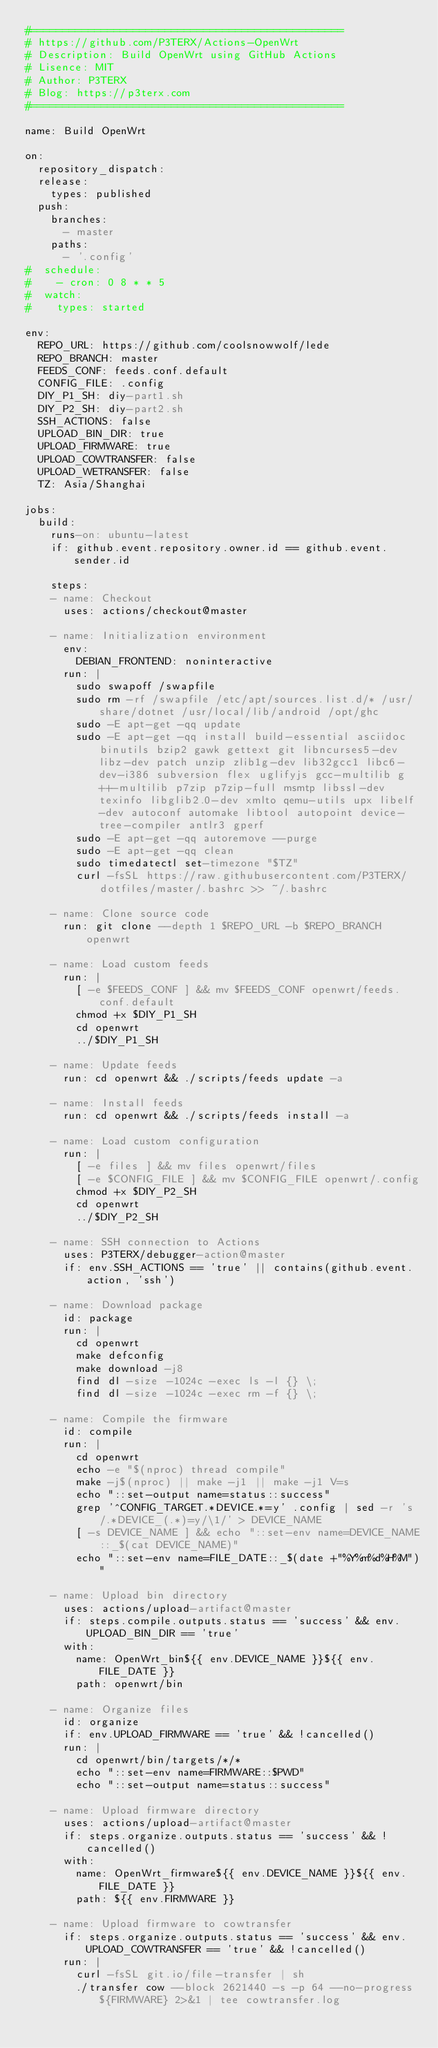<code> <loc_0><loc_0><loc_500><loc_500><_YAML_>#=================================================
# https://github.com/P3TERX/Actions-OpenWrt
# Description: Build OpenWrt using GitHub Actions
# Lisence: MIT
# Author: P3TERX
# Blog: https://p3terx.com
#=================================================

name: Build OpenWrt

on:
  repository_dispatch:
  release:
    types: published
  push:
    branches:
      - master
    paths:
      - '.config'
#  schedule:
#    - cron: 0 8 * * 5
#  watch:
#    types: started

env:
  REPO_URL: https://github.com/coolsnowwolf/lede
  REPO_BRANCH: master
  FEEDS_CONF: feeds.conf.default
  CONFIG_FILE: .config
  DIY_P1_SH: diy-part1.sh
  DIY_P2_SH: diy-part2.sh
  SSH_ACTIONS: false
  UPLOAD_BIN_DIR: true
  UPLOAD_FIRMWARE: true
  UPLOAD_COWTRANSFER: false
  UPLOAD_WETRANSFER: false
  TZ: Asia/Shanghai

jobs:
  build:
    runs-on: ubuntu-latest
    if: github.event.repository.owner.id == github.event.sender.id

    steps:
    - name: Checkout
      uses: actions/checkout@master

    - name: Initialization environment
      env:
        DEBIAN_FRONTEND: noninteractive
      run: |
        sudo swapoff /swapfile
        sudo rm -rf /swapfile /etc/apt/sources.list.d/* /usr/share/dotnet /usr/local/lib/android /opt/ghc
        sudo -E apt-get -qq update
        sudo -E apt-get -qq install build-essential asciidoc binutils bzip2 gawk gettext git libncurses5-dev libz-dev patch unzip zlib1g-dev lib32gcc1 libc6-dev-i386 subversion flex uglifyjs gcc-multilib g++-multilib p7zip p7zip-full msmtp libssl-dev texinfo libglib2.0-dev xmlto qemu-utils upx libelf-dev autoconf automake libtool autopoint device-tree-compiler antlr3 gperf
        sudo -E apt-get -qq autoremove --purge
        sudo -E apt-get -qq clean
        sudo timedatectl set-timezone "$TZ"
        curl -fsSL https://raw.githubusercontent.com/P3TERX/dotfiles/master/.bashrc >> ~/.bashrc

    - name: Clone source code
      run: git clone --depth 1 $REPO_URL -b $REPO_BRANCH openwrt

    - name: Load custom feeds
      run: |
        [ -e $FEEDS_CONF ] && mv $FEEDS_CONF openwrt/feeds.conf.default
        chmod +x $DIY_P1_SH
        cd openwrt
        ../$DIY_P1_SH

    - name: Update feeds
      run: cd openwrt && ./scripts/feeds update -a

    - name: Install feeds
      run: cd openwrt && ./scripts/feeds install -a

    - name: Load custom configuration
      run: |
        [ -e files ] && mv files openwrt/files
        [ -e $CONFIG_FILE ] && mv $CONFIG_FILE openwrt/.config
        chmod +x $DIY_P2_SH
        cd openwrt
        ../$DIY_P2_SH

    - name: SSH connection to Actions
      uses: P3TERX/debugger-action@master
      if: env.SSH_ACTIONS == 'true' || contains(github.event.action, 'ssh')

    - name: Download package
      id: package
      run: |
        cd openwrt
        make defconfig
        make download -j8
        find dl -size -1024c -exec ls -l {} \;
        find dl -size -1024c -exec rm -f {} \;

    - name: Compile the firmware
      id: compile
      run: |
        cd openwrt
        echo -e "$(nproc) thread compile"
        make -j$(nproc) || make -j1 || make -j1 V=s
        echo "::set-output name=status::success"
        grep '^CONFIG_TARGET.*DEVICE.*=y' .config | sed -r 's/.*DEVICE_(.*)=y/\1/' > DEVICE_NAME
        [ -s DEVICE_NAME ] && echo "::set-env name=DEVICE_NAME::_$(cat DEVICE_NAME)"
        echo "::set-env name=FILE_DATE::_$(date +"%Y%m%d%H%M")"

    - name: Upload bin directory
      uses: actions/upload-artifact@master
      if: steps.compile.outputs.status == 'success' && env.UPLOAD_BIN_DIR == 'true'
      with:
        name: OpenWrt_bin${{ env.DEVICE_NAME }}${{ env.FILE_DATE }}
        path: openwrt/bin

    - name: Organize files
      id: organize
      if: env.UPLOAD_FIRMWARE == 'true' && !cancelled()
      run: |
        cd openwrt/bin/targets/*/*
        echo "::set-env name=FIRMWARE::$PWD"
        echo "::set-output name=status::success"

    - name: Upload firmware directory
      uses: actions/upload-artifact@master
      if: steps.organize.outputs.status == 'success' && !cancelled()
      with:
        name: OpenWrt_firmware${{ env.DEVICE_NAME }}${{ env.FILE_DATE }}
        path: ${{ env.FIRMWARE }}

    - name: Upload firmware to cowtransfer
      if: steps.organize.outputs.status == 'success' && env.UPLOAD_COWTRANSFER == 'true' && !cancelled()
      run: |
        curl -fsSL git.io/file-transfer | sh
        ./transfer cow --block 2621440 -s -p 64 --no-progress ${FIRMWARE} 2>&1 | tee cowtransfer.log</code> 